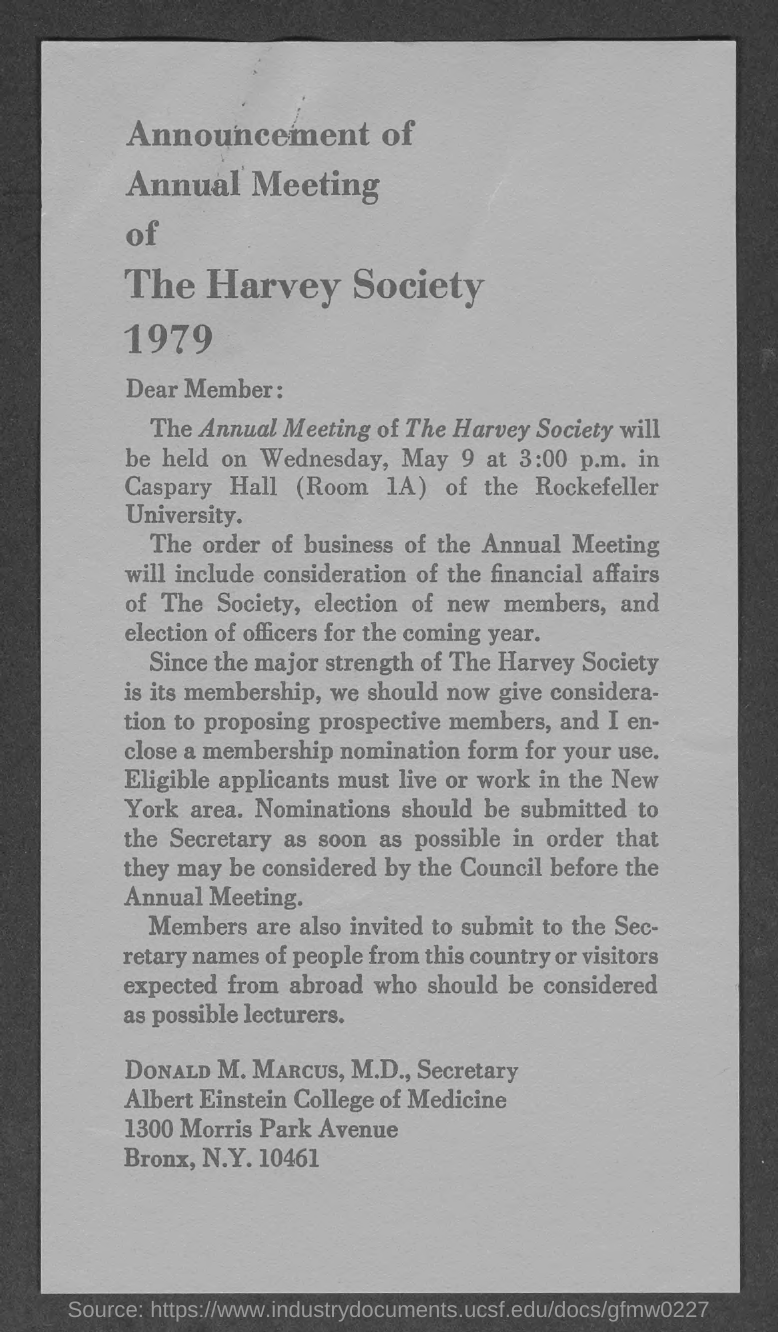When is the Annual Meeting of The Harvey Society held?
Provide a short and direct response. Wednesday, May 9 at 3:00 p.m. Where is the Annual Meeting of The Harvey Society organized?
Ensure brevity in your answer.  Caspary Hall (Room 1A) of the Rockefeller Univeristy. What is the designation of DONALD M. MARCUS, M.D.?
Your answer should be very brief. Secretary. 